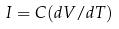Convert formula to latex. <formula><loc_0><loc_0><loc_500><loc_500>I = C ( d V / d T )</formula> 